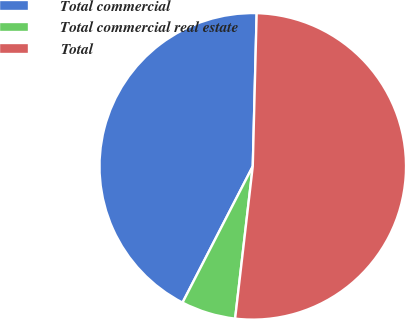Convert chart. <chart><loc_0><loc_0><loc_500><loc_500><pie_chart><fcel>Total commercial<fcel>Total commercial real estate<fcel>Total<nl><fcel>42.83%<fcel>5.74%<fcel>51.43%<nl></chart> 